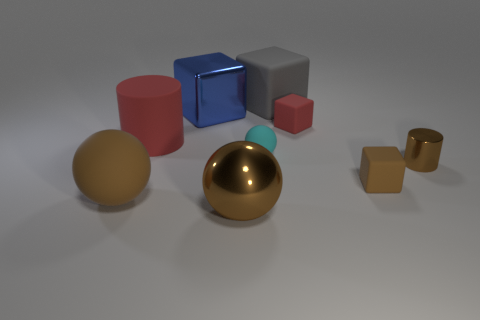Can you describe the shapes and their materials in the image? Certainly! The image showcases a variety of geometric shapes with different materials. There is a large gold matte sphere, and a smaller gold shiny sphere, indicating two materials: matte and reflective. There are also two cylinders, one red with a rubber texture and one made of shiny metal. Next, there is a red cube with a rubber texture and a couple of blocks - a large silver metal one and a smaller brown one that appear to be made of a matte surface which could be wood or plastic. Lastly, we have the tiny cyan matte ball mentioned earlier.  What time of day does the lighting in the scene suggest? The lighting in the scene doesn't strongly suggest any particular time of day, as it appears to be a controlled environment with artificial lighting. The soft shadows and the even illumination on the objects suggest an indoor setting with studio lights that provide a consistent and diffuse source of light. 